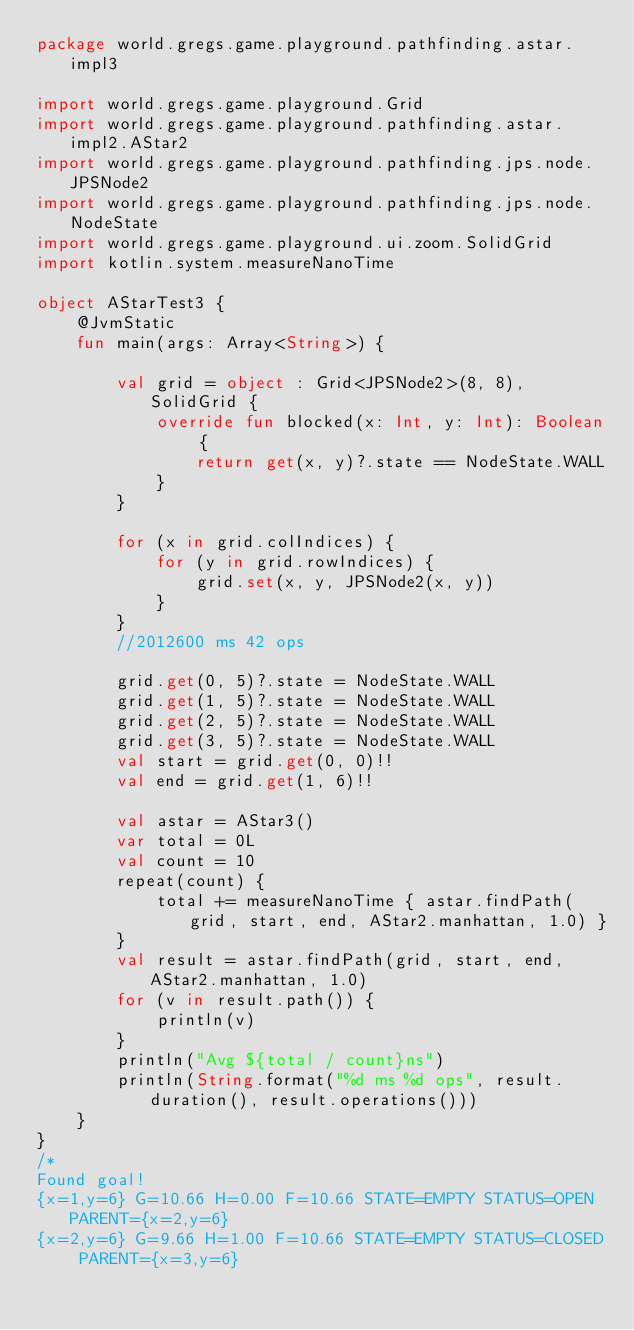Convert code to text. <code><loc_0><loc_0><loc_500><loc_500><_Kotlin_>package world.gregs.game.playground.pathfinding.astar.impl3

import world.gregs.game.playground.Grid
import world.gregs.game.playground.pathfinding.astar.impl2.AStar2
import world.gregs.game.playground.pathfinding.jps.node.JPSNode2
import world.gregs.game.playground.pathfinding.jps.node.NodeState
import world.gregs.game.playground.ui.zoom.SolidGrid
import kotlin.system.measureNanoTime

object AStarTest3 {
    @JvmStatic
    fun main(args: Array<String>) {

        val grid = object : Grid<JPSNode2>(8, 8), SolidGrid {
            override fun blocked(x: Int, y: Int): Boolean {
                return get(x, y)?.state == NodeState.WALL
            }
        }

        for (x in grid.colIndices) {
            for (y in grid.rowIndices) {
                grid.set(x, y, JPSNode2(x, y))
            }
        }
        //2012600 ms 42 ops

        grid.get(0, 5)?.state = NodeState.WALL
        grid.get(1, 5)?.state = NodeState.WALL
        grid.get(2, 5)?.state = NodeState.WALL
        grid.get(3, 5)?.state = NodeState.WALL
        val start = grid.get(0, 0)!!
        val end = grid.get(1, 6)!!

        val astar = AStar3()
        var total = 0L
        val count = 10
        repeat(count) {
            total += measureNanoTime { astar.findPath(grid, start, end, AStar2.manhattan, 1.0) }
        }
        val result = astar.findPath(grid, start, end, AStar2.manhattan, 1.0)
        for (v in result.path()) {
            println(v)
        }
        println("Avg ${total / count}ns")
        println(String.format("%d ms %d ops", result.duration(), result.operations()))
    }
}
/*
Found goal!
{x=1,y=6} G=10.66 H=0.00 F=10.66 STATE=EMPTY STATUS=OPEN PARENT={x=2,y=6}
{x=2,y=6} G=9.66 H=1.00 F=10.66 STATE=EMPTY STATUS=CLOSED PARENT={x=3,y=6}</code> 